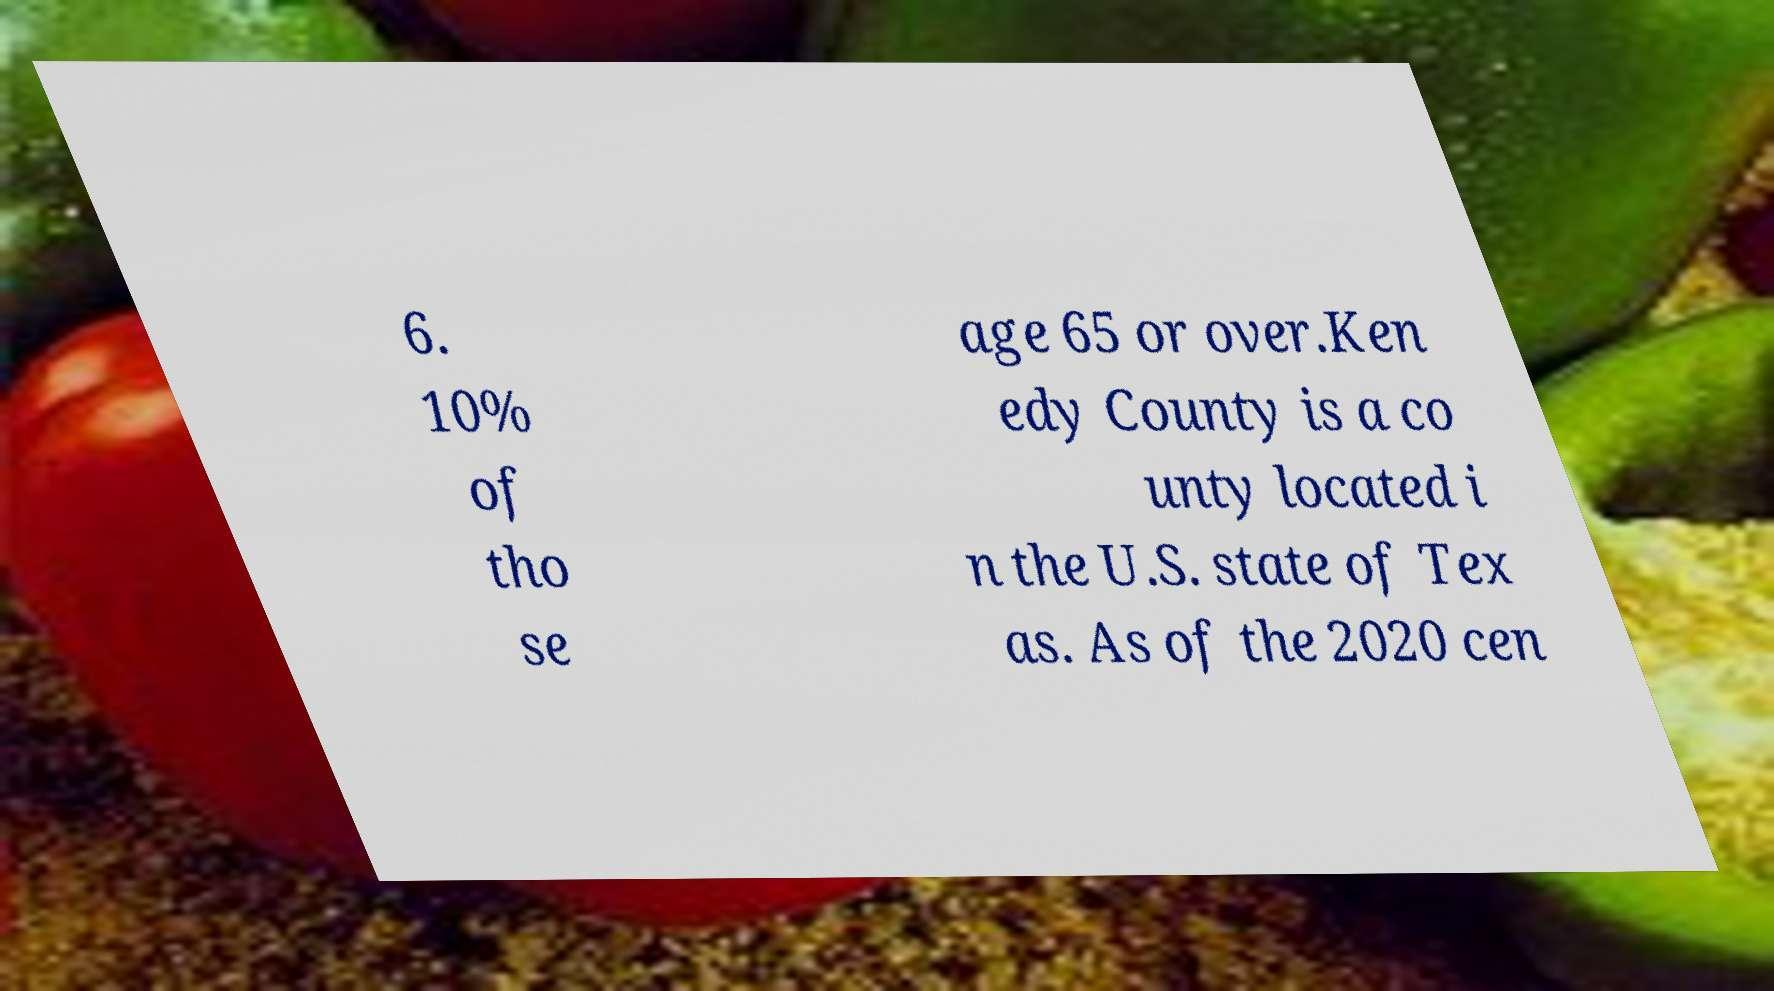Please read and relay the text visible in this image. What does it say? 6. 10% of tho se age 65 or over.Ken edy County is a co unty located i n the U.S. state of Tex as. As of the 2020 cen 